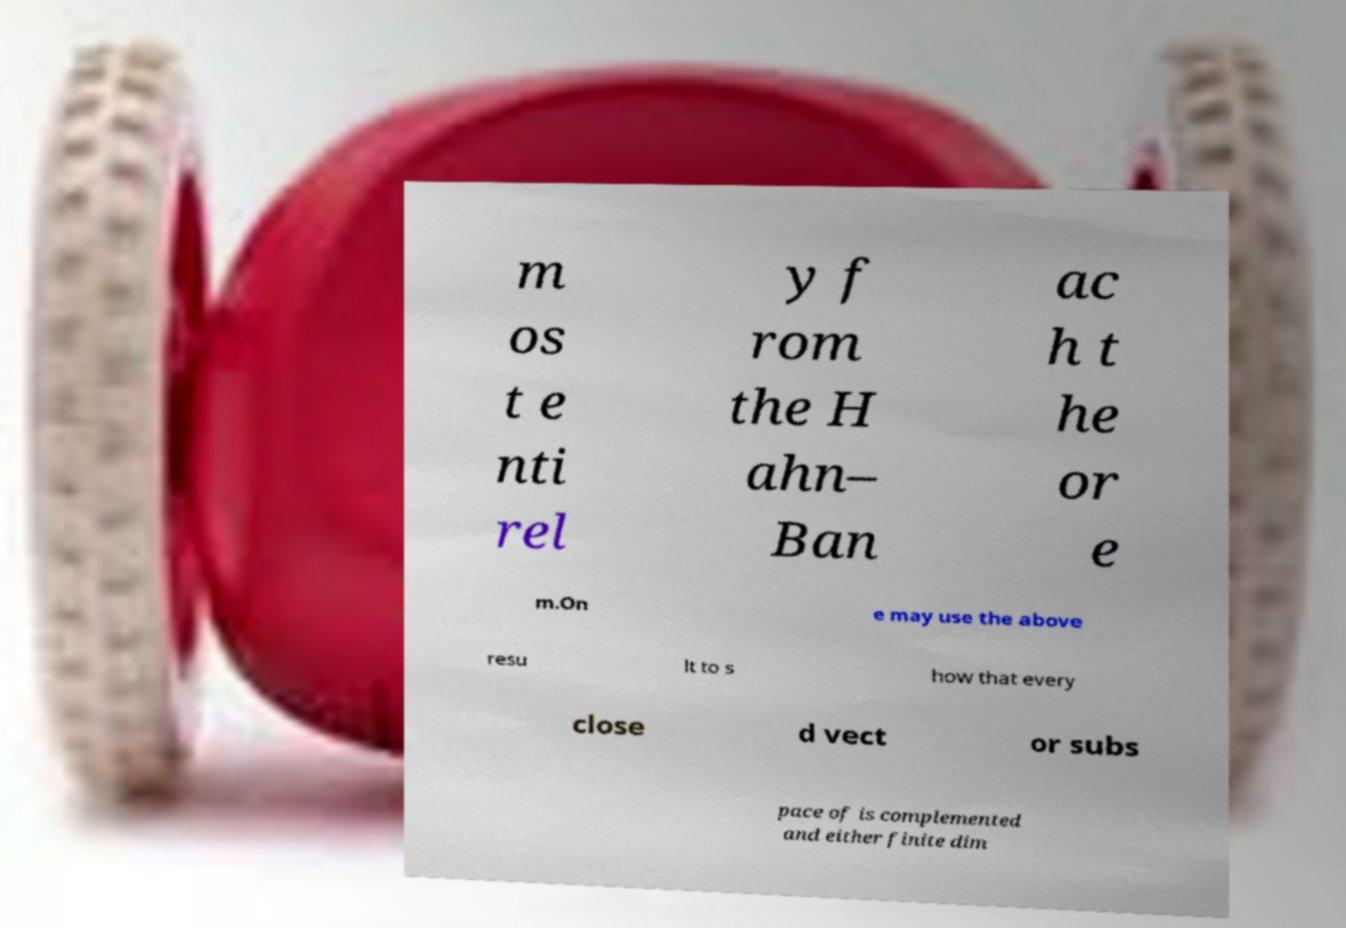I need the written content from this picture converted into text. Can you do that? m os t e nti rel y f rom the H ahn– Ban ac h t he or e m.On e may use the above resu lt to s how that every close d vect or subs pace of is complemented and either finite dim 